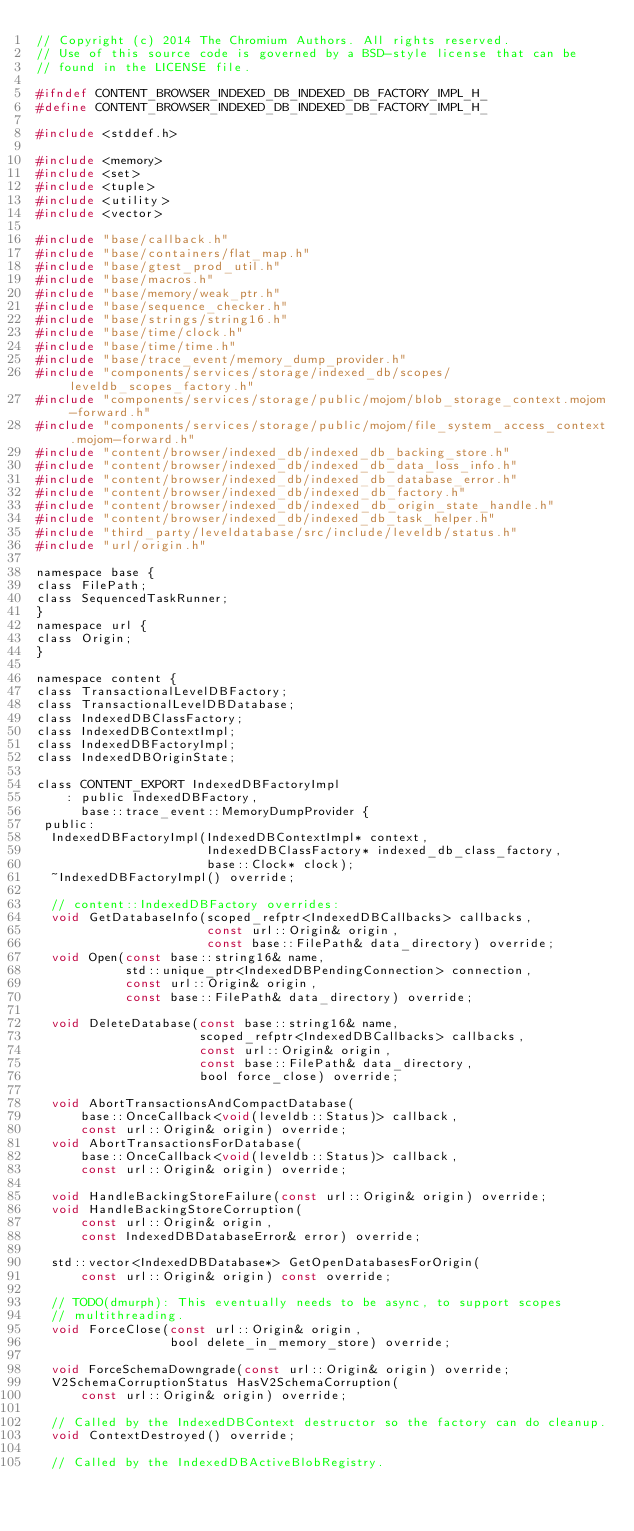<code> <loc_0><loc_0><loc_500><loc_500><_C_>// Copyright (c) 2014 The Chromium Authors. All rights reserved.
// Use of this source code is governed by a BSD-style license that can be
// found in the LICENSE file.

#ifndef CONTENT_BROWSER_INDEXED_DB_INDEXED_DB_FACTORY_IMPL_H_
#define CONTENT_BROWSER_INDEXED_DB_INDEXED_DB_FACTORY_IMPL_H_

#include <stddef.h>

#include <memory>
#include <set>
#include <tuple>
#include <utility>
#include <vector>

#include "base/callback.h"
#include "base/containers/flat_map.h"
#include "base/gtest_prod_util.h"
#include "base/macros.h"
#include "base/memory/weak_ptr.h"
#include "base/sequence_checker.h"
#include "base/strings/string16.h"
#include "base/time/clock.h"
#include "base/time/time.h"
#include "base/trace_event/memory_dump_provider.h"
#include "components/services/storage/indexed_db/scopes/leveldb_scopes_factory.h"
#include "components/services/storage/public/mojom/blob_storage_context.mojom-forward.h"
#include "components/services/storage/public/mojom/file_system_access_context.mojom-forward.h"
#include "content/browser/indexed_db/indexed_db_backing_store.h"
#include "content/browser/indexed_db/indexed_db_data_loss_info.h"
#include "content/browser/indexed_db/indexed_db_database_error.h"
#include "content/browser/indexed_db/indexed_db_factory.h"
#include "content/browser/indexed_db/indexed_db_origin_state_handle.h"
#include "content/browser/indexed_db/indexed_db_task_helper.h"
#include "third_party/leveldatabase/src/include/leveldb/status.h"
#include "url/origin.h"

namespace base {
class FilePath;
class SequencedTaskRunner;
}
namespace url {
class Origin;
}

namespace content {
class TransactionalLevelDBFactory;
class TransactionalLevelDBDatabase;
class IndexedDBClassFactory;
class IndexedDBContextImpl;
class IndexedDBFactoryImpl;
class IndexedDBOriginState;

class CONTENT_EXPORT IndexedDBFactoryImpl
    : public IndexedDBFactory,
      base::trace_event::MemoryDumpProvider {
 public:
  IndexedDBFactoryImpl(IndexedDBContextImpl* context,
                       IndexedDBClassFactory* indexed_db_class_factory,
                       base::Clock* clock);
  ~IndexedDBFactoryImpl() override;

  // content::IndexedDBFactory overrides:
  void GetDatabaseInfo(scoped_refptr<IndexedDBCallbacks> callbacks,
                       const url::Origin& origin,
                       const base::FilePath& data_directory) override;
  void Open(const base::string16& name,
            std::unique_ptr<IndexedDBPendingConnection> connection,
            const url::Origin& origin,
            const base::FilePath& data_directory) override;

  void DeleteDatabase(const base::string16& name,
                      scoped_refptr<IndexedDBCallbacks> callbacks,
                      const url::Origin& origin,
                      const base::FilePath& data_directory,
                      bool force_close) override;

  void AbortTransactionsAndCompactDatabase(
      base::OnceCallback<void(leveldb::Status)> callback,
      const url::Origin& origin) override;
  void AbortTransactionsForDatabase(
      base::OnceCallback<void(leveldb::Status)> callback,
      const url::Origin& origin) override;

  void HandleBackingStoreFailure(const url::Origin& origin) override;
  void HandleBackingStoreCorruption(
      const url::Origin& origin,
      const IndexedDBDatabaseError& error) override;

  std::vector<IndexedDBDatabase*> GetOpenDatabasesForOrigin(
      const url::Origin& origin) const override;

  // TODO(dmurph): This eventually needs to be async, to support scopes
  // multithreading.
  void ForceClose(const url::Origin& origin,
                  bool delete_in_memory_store) override;

  void ForceSchemaDowngrade(const url::Origin& origin) override;
  V2SchemaCorruptionStatus HasV2SchemaCorruption(
      const url::Origin& origin) override;

  // Called by the IndexedDBContext destructor so the factory can do cleanup.
  void ContextDestroyed() override;

  // Called by the IndexedDBActiveBlobRegistry.</code> 